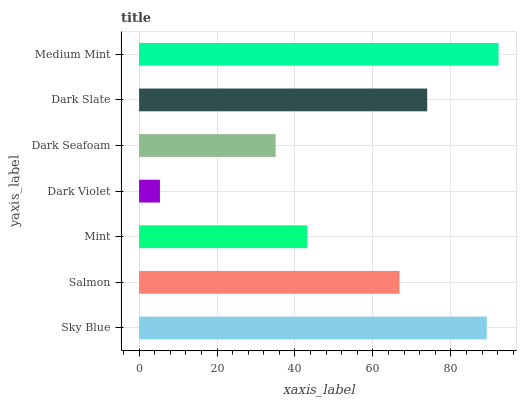Is Dark Violet the minimum?
Answer yes or no. Yes. Is Medium Mint the maximum?
Answer yes or no. Yes. Is Salmon the minimum?
Answer yes or no. No. Is Salmon the maximum?
Answer yes or no. No. Is Sky Blue greater than Salmon?
Answer yes or no. Yes. Is Salmon less than Sky Blue?
Answer yes or no. Yes. Is Salmon greater than Sky Blue?
Answer yes or no. No. Is Sky Blue less than Salmon?
Answer yes or no. No. Is Salmon the high median?
Answer yes or no. Yes. Is Salmon the low median?
Answer yes or no. Yes. Is Medium Mint the high median?
Answer yes or no. No. Is Dark Seafoam the low median?
Answer yes or no. No. 